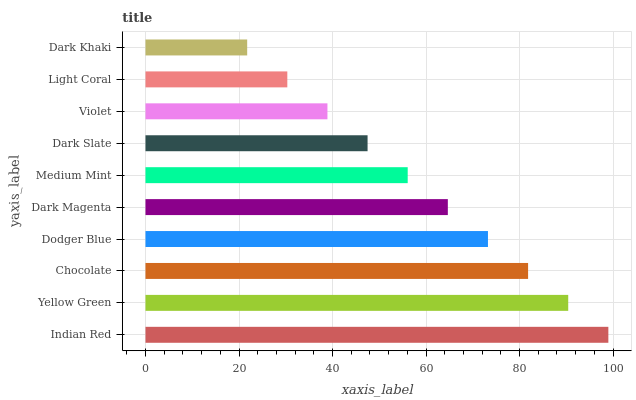Is Dark Khaki the minimum?
Answer yes or no. Yes. Is Indian Red the maximum?
Answer yes or no. Yes. Is Yellow Green the minimum?
Answer yes or no. No. Is Yellow Green the maximum?
Answer yes or no. No. Is Indian Red greater than Yellow Green?
Answer yes or no. Yes. Is Yellow Green less than Indian Red?
Answer yes or no. Yes. Is Yellow Green greater than Indian Red?
Answer yes or no. No. Is Indian Red less than Yellow Green?
Answer yes or no. No. Is Dark Magenta the high median?
Answer yes or no. Yes. Is Medium Mint the low median?
Answer yes or no. Yes. Is Yellow Green the high median?
Answer yes or no. No. Is Yellow Green the low median?
Answer yes or no. No. 